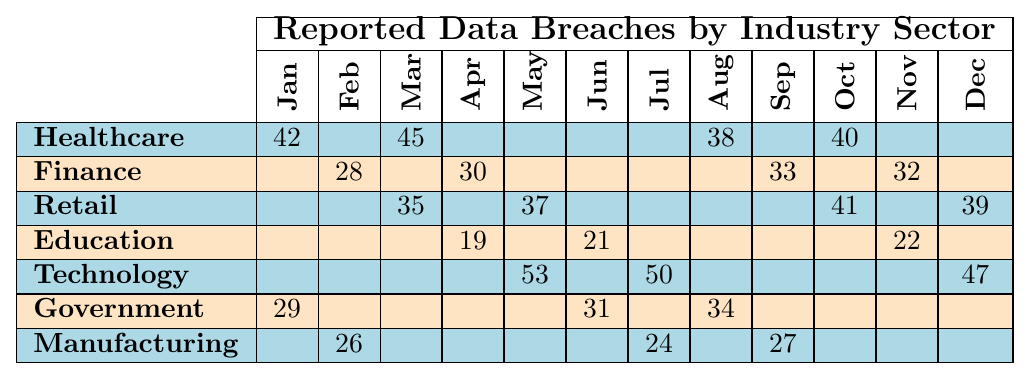What is the total number of reported data breaches in the Healthcare sector over the year? Summing the monthly counts for Healthcare: (42 + 45 + 38 + 40) = 165
Answer: 165 Which month had the highest number of breaches in the Technology sector? In the Technology sector, the counts are: May (53), July (50), December (47). The highest is in May (53).
Answer: May Did the Government sector experience more breaches in the first half of the year than the second half? In the first half (Jan-Jun), Government had 29 (Jan) + 31 (Jun) = 60 breaches. In the second half (Jul-Dec), it had 34 (Aug) = 34 breaches. Since 60 > 34, they experienced more breaches in the first half.
Answer: Yes What is the average number of breaches reported in the Retail sector over the year? Summing the Retail counts: (35 + 37 + 41 + 39) = 152; there are 4 months, so the average = 152 / 4 = 38.
Answer: 38 Is it true that the Manufacturing sector had the least number of breaches in February compared to the other sectors? The Manufacturing count in February is 26. Other sectors have: Healthcare (none), Finance (28), Retail (none), Education (none), Technology (none), Government (none) - so 26 is indeed the least.
Answer: Yes What is the difference between the highest and lowest number of breaches in the Education sector? In the Education sector, the counts are: 19 (Apr) and 22 (Nov). The difference is 22 - 19 = 3.
Answer: 3 Across all sectors, which month had the highest combined count of reported breaches? The counts are: May (53+37+47 = 137), August (38+34 = 72), October (40+41 = 81), etc. The highest is in May (137).
Answer: May How many more breaches did the Finance sector have in September compared to January? The Finance counts are: September (33) and January (none). So the difference is 33 - 0 = 33.
Answer: 33 Which sector experienced the most breaches in June, and how many breaches were reported? The counts for June are: Education (21), Technology (none), Government (31), Manufacturing (none). Government had the most with 31 breaches.
Answer: Government, 31 What was the total number of breaches reported in the months from Jan to Jun for the Healthcare sector? The Healthcare counts from Jan to Jun are: 42 (Jan) + 45 (Mar) + 38 (Aug) + (none for Feb, Apr, and Jun) = 125.
Answer: 125 Was there any month when the Retail sector reported more breaches than the Technology sector? In May, Retail reported 37 and Technology reported 53. In Dec, Retail reported 39 while Technology reported 47. In no month did Retail exceed Technology.
Answer: No 